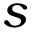Convert formula to latex. <formula><loc_0><loc_0><loc_500><loc_500>s</formula> 